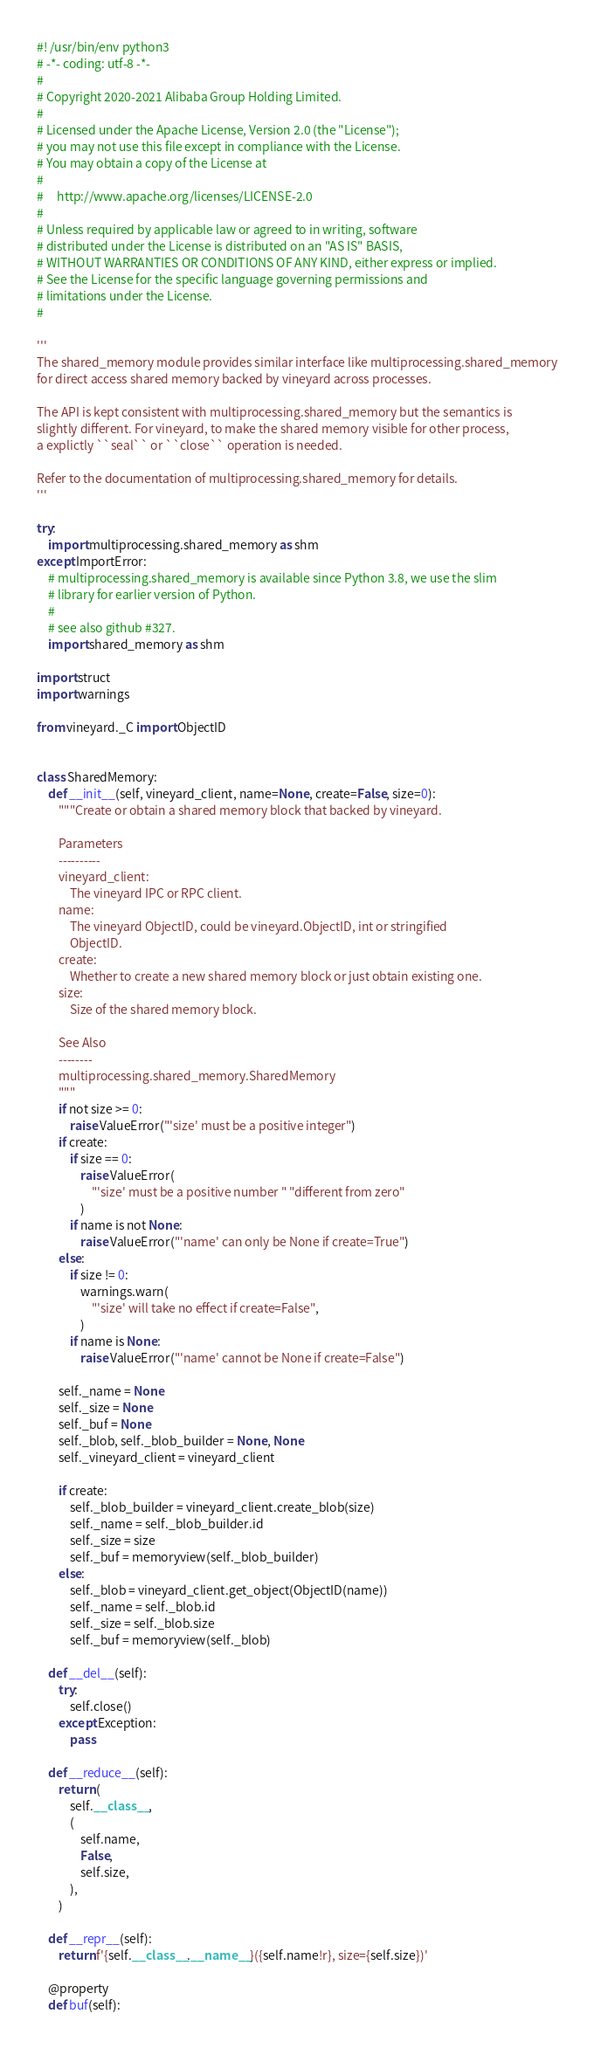<code> <loc_0><loc_0><loc_500><loc_500><_Python_>#! /usr/bin/env python3
# -*- coding: utf-8 -*-
#
# Copyright 2020-2021 Alibaba Group Holding Limited.
#
# Licensed under the Apache License, Version 2.0 (the "License");
# you may not use this file except in compliance with the License.
# You may obtain a copy of the License at
#
#     http://www.apache.org/licenses/LICENSE-2.0
#
# Unless required by applicable law or agreed to in writing, software
# distributed under the License is distributed on an "AS IS" BASIS,
# WITHOUT WARRANTIES OR CONDITIONS OF ANY KIND, either express or implied.
# See the License for the specific language governing permissions and
# limitations under the License.
#

'''
The shared_memory module provides similar interface like multiprocessing.shared_memory
for direct access shared memory backed by vineyard across processes.

The API is kept consistent with multiprocessing.shared_memory but the semantics is
slightly different. For vineyard, to make the shared memory visible for other process,
a explictly ``seal`` or ``close`` operation is needed.

Refer to the documentation of multiprocessing.shared_memory for details.
'''

try:
    import multiprocessing.shared_memory as shm
except ImportError:
    # multiprocessing.shared_memory is available since Python 3.8, we use the slim
    # library for earlier version of Python.
    #
    # see also github #327.
    import shared_memory as shm

import struct
import warnings

from vineyard._C import ObjectID


class SharedMemory:
    def __init__(self, vineyard_client, name=None, create=False, size=0):
        """Create or obtain a shared memory block that backed by vineyard.

        Parameters
        ----------
        vineyard_client:
            The vineyard IPC or RPC client.
        name:
            The vineyard ObjectID, could be vineyard.ObjectID, int or stringified
            ObjectID.
        create:
            Whether to create a new shared memory block or just obtain existing one.
        size:
            Size of the shared memory block.

        See Also
        --------
        multiprocessing.shared_memory.SharedMemory
        """
        if not size >= 0:
            raise ValueError("'size' must be a positive integer")
        if create:
            if size == 0:
                raise ValueError(
                    "'size' must be a positive number " "different from zero"
                )
            if name is not None:
                raise ValueError("'name' can only be None if create=True")
        else:
            if size != 0:
                warnings.warn(
                    "'size' will take no effect if create=False",
                )
            if name is None:
                raise ValueError("'name' cannot be None if create=False")

        self._name = None
        self._size = None
        self._buf = None
        self._blob, self._blob_builder = None, None
        self._vineyard_client = vineyard_client

        if create:
            self._blob_builder = vineyard_client.create_blob(size)
            self._name = self._blob_builder.id
            self._size = size
            self._buf = memoryview(self._blob_builder)
        else:
            self._blob = vineyard_client.get_object(ObjectID(name))
            self._name = self._blob.id
            self._size = self._blob.size
            self._buf = memoryview(self._blob)

    def __del__(self):
        try:
            self.close()
        except Exception:
            pass

    def __reduce__(self):
        return (
            self.__class__,
            (
                self.name,
                False,
                self.size,
            ),
        )

    def __repr__(self):
        return f'{self.__class__.__name__}({self.name!r}, size={self.size})'

    @property
    def buf(self):</code> 